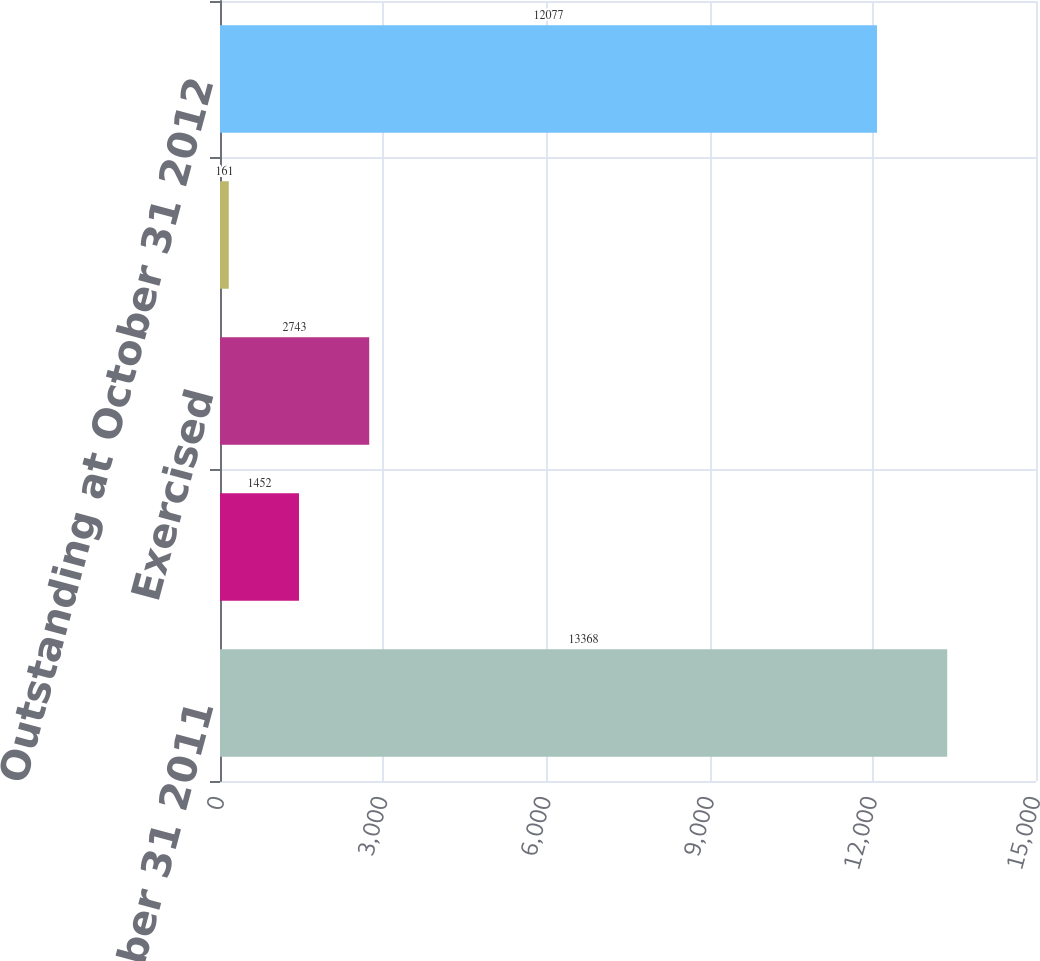Convert chart to OTSL. <chart><loc_0><loc_0><loc_500><loc_500><bar_chart><fcel>Outstanding at October 31 2011<fcel>Granted<fcel>Exercised<fcel>Cancelled/Forfeited/Expired<fcel>Outstanding at October 31 2012<nl><fcel>13368<fcel>1452<fcel>2743<fcel>161<fcel>12077<nl></chart> 